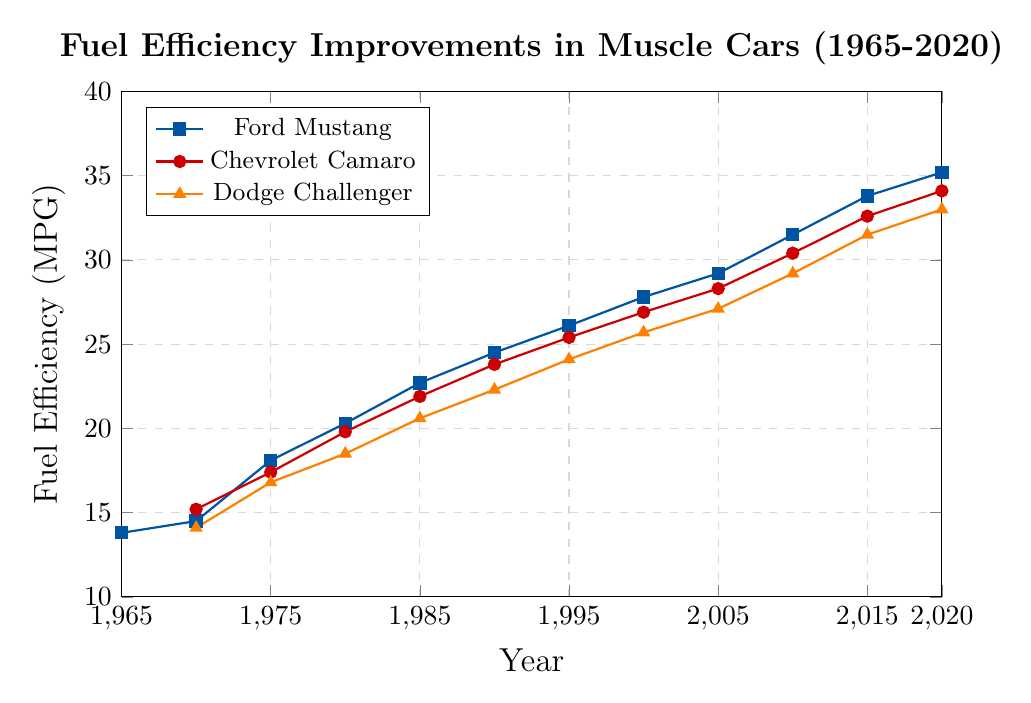Which car model had the highest fuel efficiency in 2020? Look at the '2020' data points for Ford Mustang, Chevrolet Camaro, and Dodge Challenger. Identify the highest MPG value among them. Ford Mustang has 35.2, Chevrolet Camaro has 34.1, Dodge Challenger has 33.0. Mustang has the highest.
Answer: Ford Mustang Which car model showed the greatest improvement in fuel efficiency from 1970 to 2020? Compute the difference in fuel efficiency for each car model between 2020 and 1970. Ford Mustang: 35.2 - 14.5 = 20.7, Chevrolet Camaro: 34.1 - 15.2 = 18.9, Dodge Challenger: 33.0 - 14.1 = 18.9. Therefore, Mustang showed the greatest improvement.
Answer: Ford Mustang What was the average fuel efficiency of Chevrolet Camaro in 1990 and 2020? Calculate the average of the 1990 and 2020 fuel efficiency values for Chevrolet Camaro. (23.8 + 34.1) / 2 = 28.95
Answer: 28.95 When did the Dodge Challenger reach a fuel efficiency of at least 30 MPG first? Identify the first year when the fuel efficiency of Dodge Challenger is at least 30 MPG. Check the data points for 29.2 (2010) and 31.5 (2015), so it reached in 2015.
Answer: 2015 Between Ford Mustang and Dodge Challenger, which had better fuel efficiency in 2015, and by how much? Compare the 2015 fuel efficiency values for Ford Mustang and Dodge Challenger. Mustang has 33.8, Challenger has 31.5. The difference is 33.8 - 31.5 = 2.3
Answer: Ford Mustang by 2.3 MPG What's the visual attribute used to differentiate Ford Mustang from the other car models in the plot? Identify the colors and marker shapes used in the plot. Ford Mustang is represented by a blue line with square markers.
Answer: Blue color with square markers Which model had a greater increase in fuel efficiency between 1980 and 2000, Ford Mustang or Chevrolet Camaro? Calculate the increase in fuel efficiency for both models between 1980 and 2000. Mustang: 27.8 - 20.3 = 7.5, Camaro: 26.9 - 19.8 = 7.1. Mustang had the greater increase.
Answer: Ford Mustang Among the three car models, which has the lowest fuel efficiency in 1975, and what is the value? Identify the lowest MPG value in 1975 for the three models. Ford Mustang has 18.1, Chevrolet Camaro has 17.4, Dodge Challenger has 16.8. Challenger has the lowest.
Answer: Dodge Challenger with 16.8 MPG 